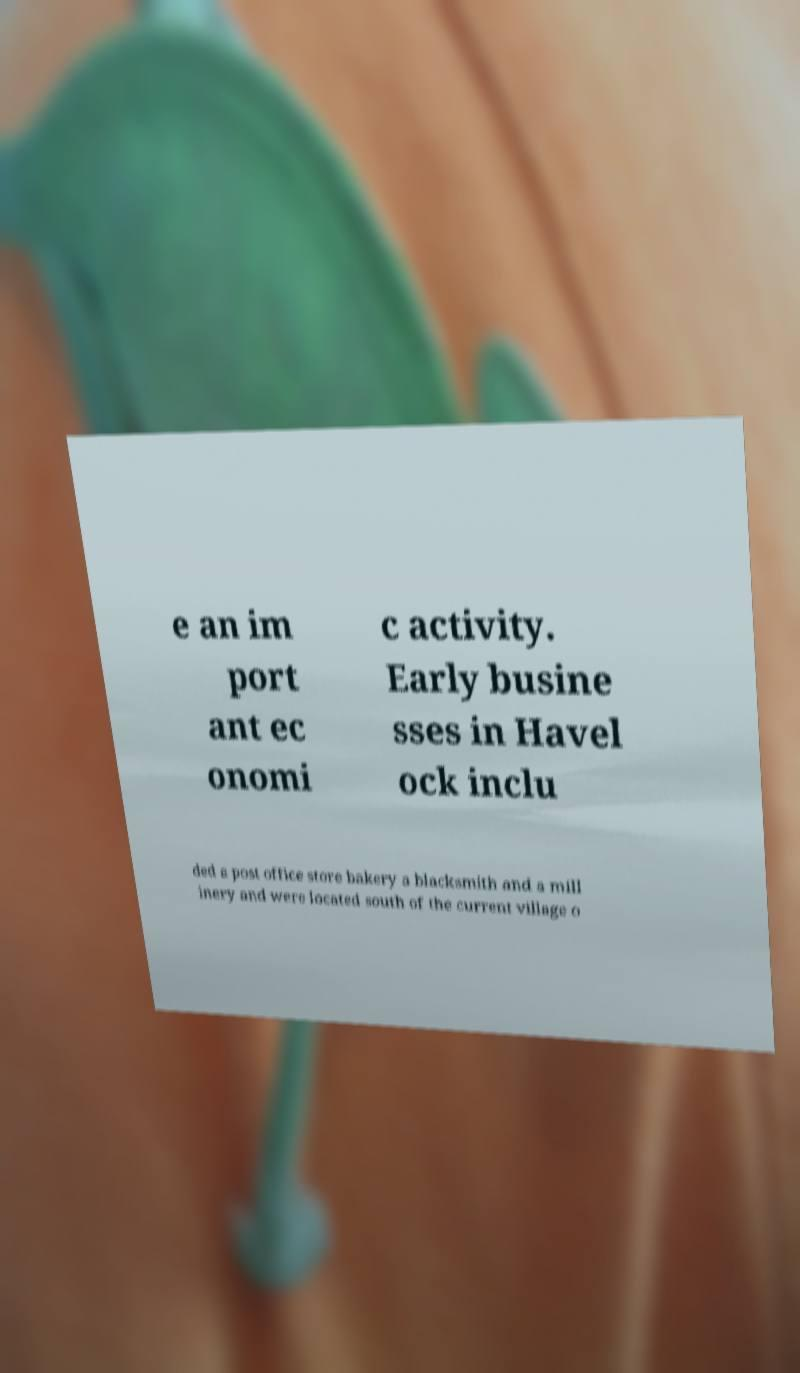Could you extract and type out the text from this image? e an im port ant ec onomi c activity. Early busine sses in Havel ock inclu ded a post office store bakery a blacksmith and a mill inery and were located south of the current village o 